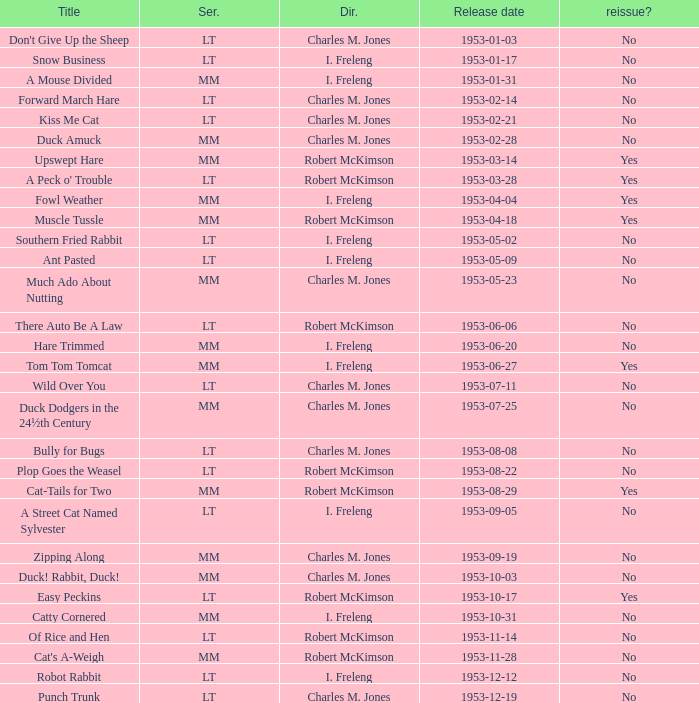What's the release date of Forward March Hare? 1953-02-14. 